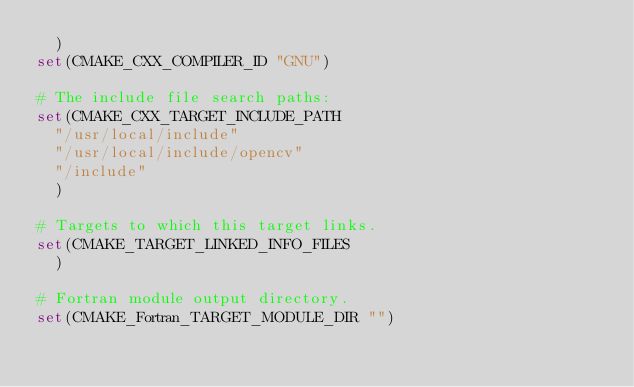Convert code to text. <code><loc_0><loc_0><loc_500><loc_500><_CMake_>  )
set(CMAKE_CXX_COMPILER_ID "GNU")

# The include file search paths:
set(CMAKE_CXX_TARGET_INCLUDE_PATH
  "/usr/local/include"
  "/usr/local/include/opencv"
  "/include"
  )

# Targets to which this target links.
set(CMAKE_TARGET_LINKED_INFO_FILES
  )

# Fortran module output directory.
set(CMAKE_Fortran_TARGET_MODULE_DIR "")
</code> 